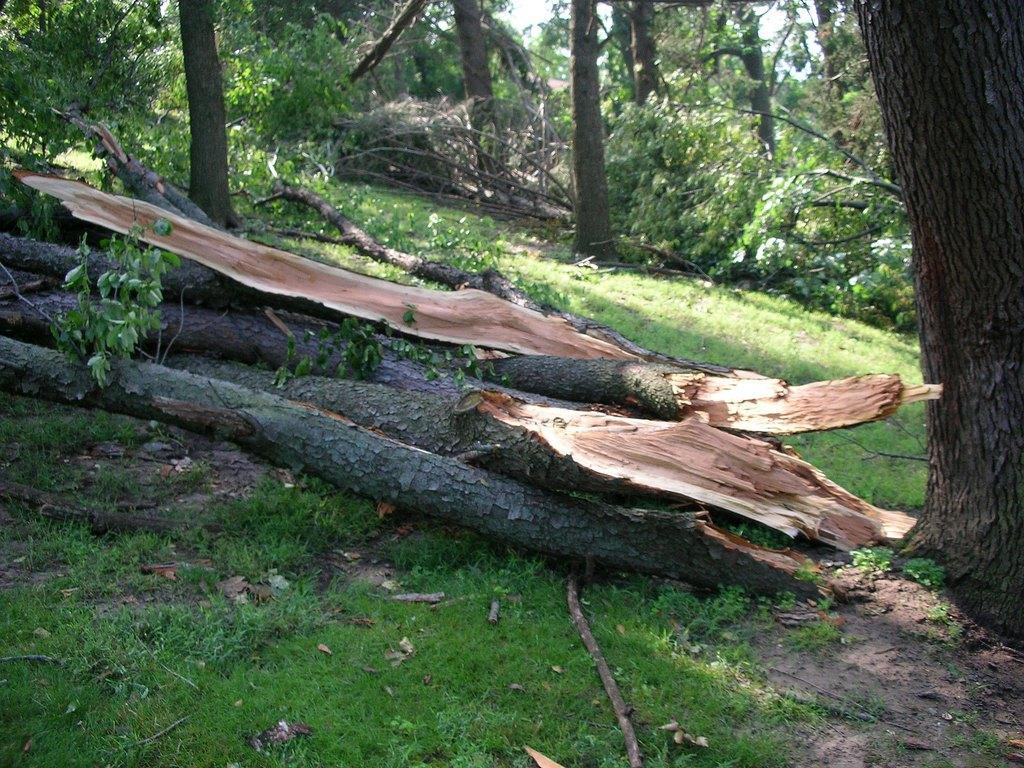In one or two sentences, can you explain what this image depicts? In this image I can see the ground, some grass on the ground and few wooden logs which are cream, brown and black in color. In the background I can see few trees and the sky. 